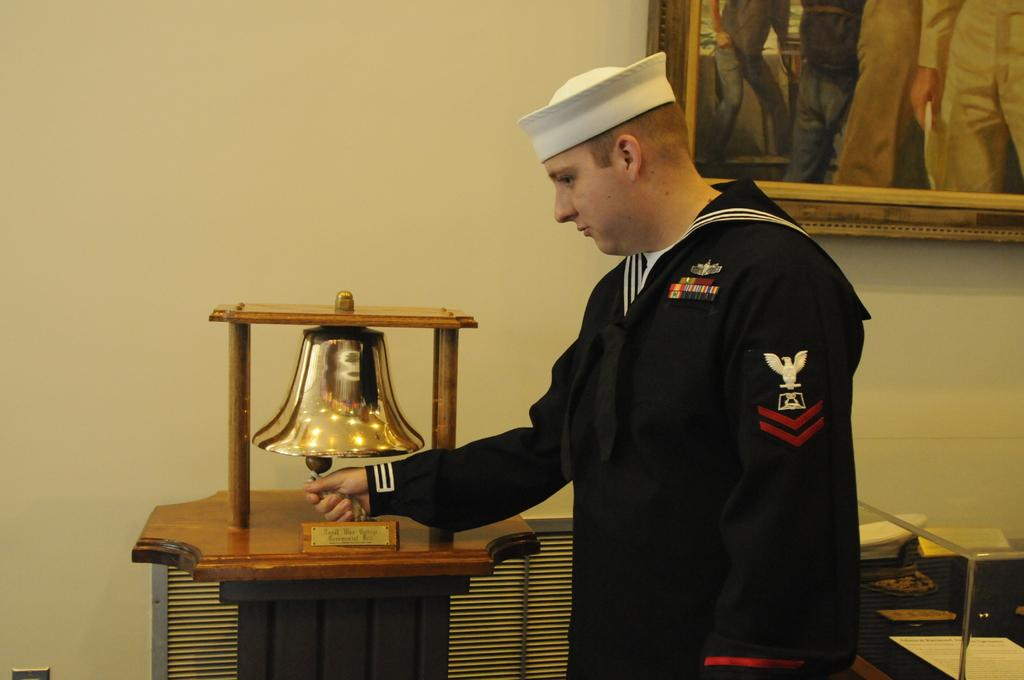Who is in the image? There is a person in the image. What is the person doing in the image? The person is ringing a bell. What can be seen on the wall in the image? There is a wooden photo frame on the wall in the image. What type of print can be seen on the ant's back in the image? There are no ants present in the image, and therefore no prints on their backs can be observed. 